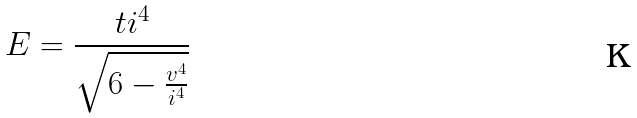<formula> <loc_0><loc_0><loc_500><loc_500>E = \frac { t i ^ { 4 } } { \sqrt { 6 - \frac { v ^ { 4 } } { i ^ { 4 } } } }</formula> 